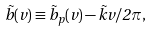Convert formula to latex. <formula><loc_0><loc_0><loc_500><loc_500>\vec { b } ( v ) \equiv \vec { b } _ { p } ( v ) - \vec { k } v / 2 \pi ,</formula> 